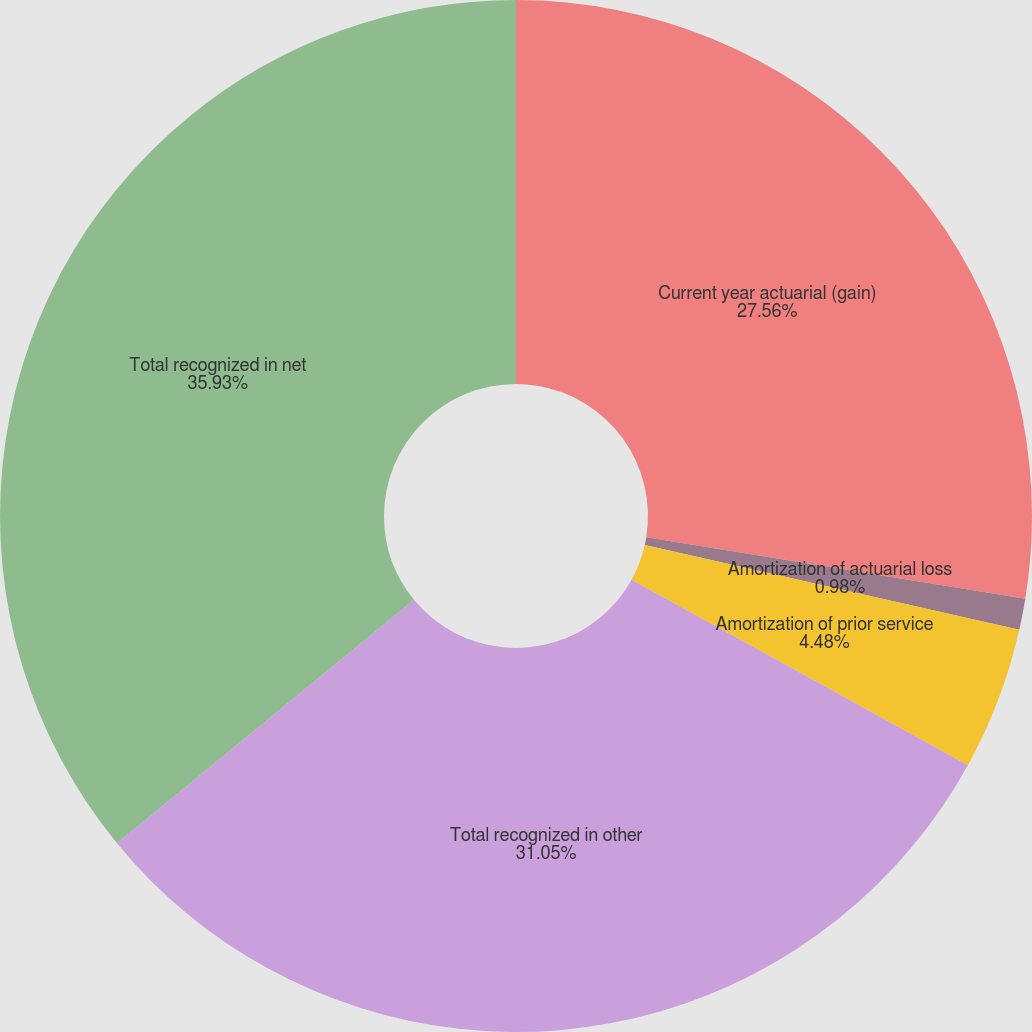<chart> <loc_0><loc_0><loc_500><loc_500><pie_chart><fcel>Current year actuarial (gain)<fcel>Amortization of actuarial loss<fcel>Amortization of prior service<fcel>Total recognized in other<fcel>Total recognized in net<nl><fcel>27.56%<fcel>0.98%<fcel>4.48%<fcel>31.05%<fcel>35.93%<nl></chart> 